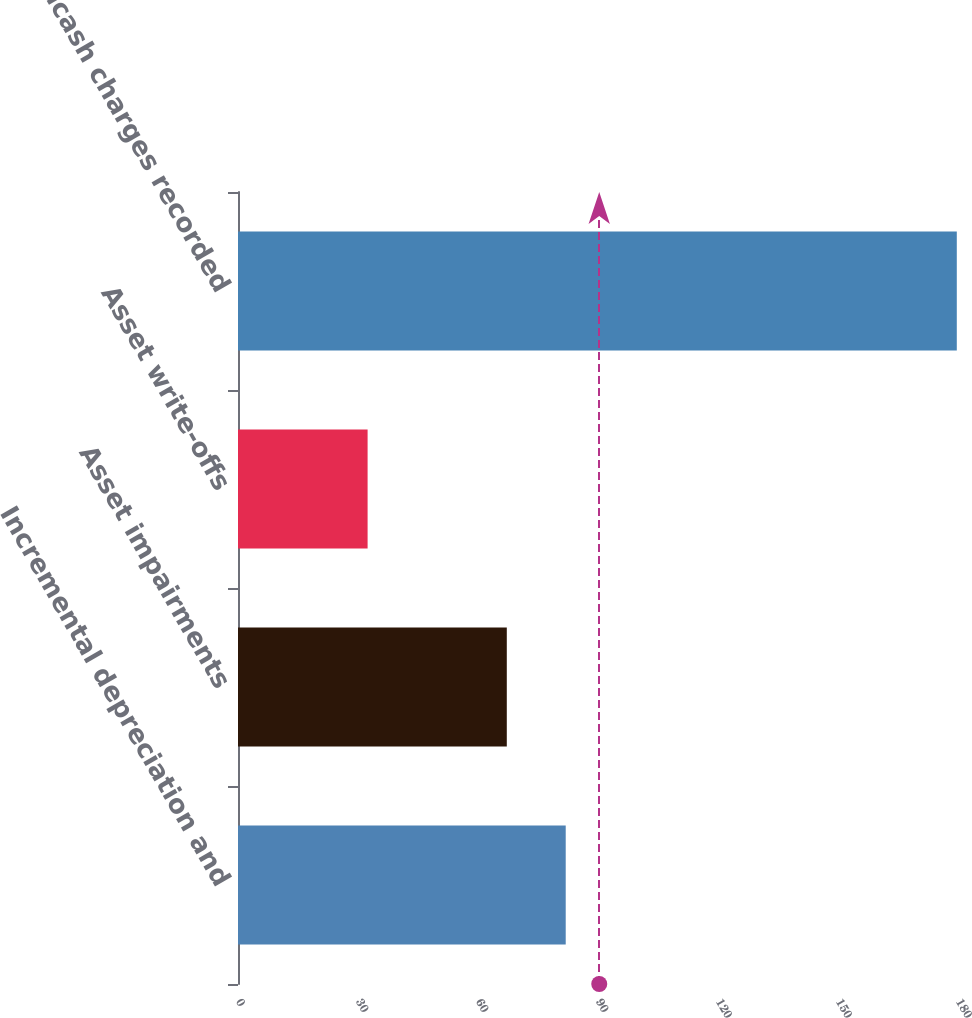Convert chart. <chart><loc_0><loc_0><loc_500><loc_500><bar_chart><fcel>Incremental depreciation and<fcel>Asset impairments<fcel>Asset write-offs<fcel>Noncash charges recorded<nl><fcel>81.93<fcel>67.2<fcel>32.4<fcel>179.7<nl></chart> 